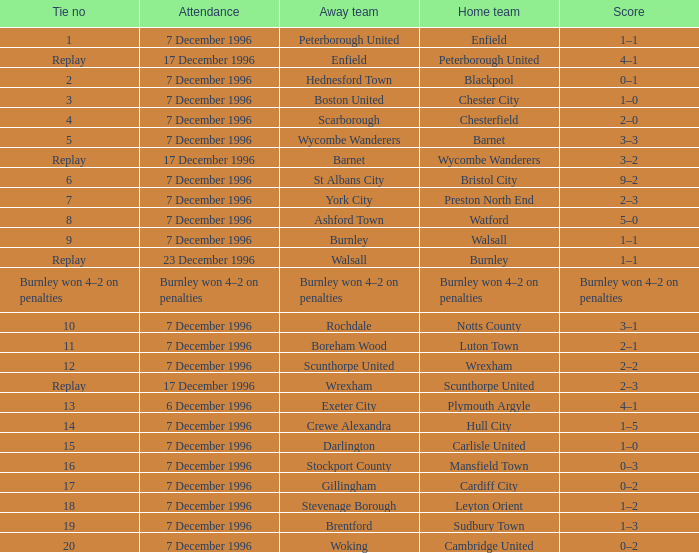What was the attendance for the home team of Walsall? 7 December 1996. 